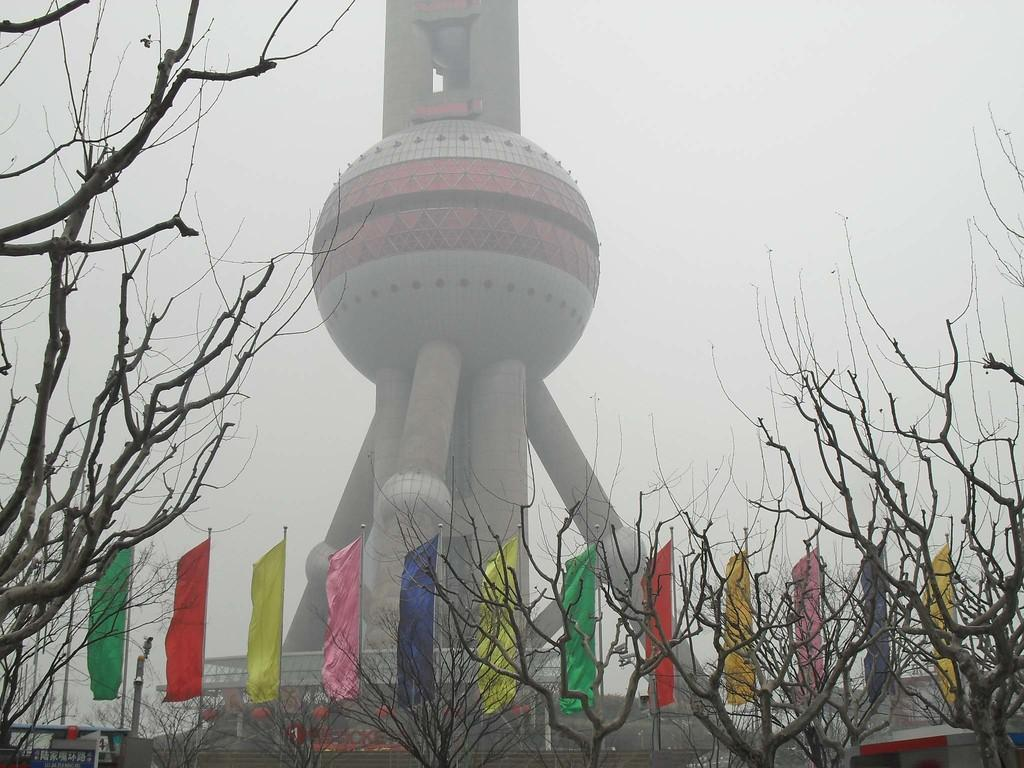What is the main structure in the image? There is a tower in the image. What is attached to the poles in the image? There are flags on poles in the image. What type of vegetation can be seen in the image? There is a group of trees in the image. What type of man-made structures are present in the image? There are buildings in the image. What else can be seen attached to the poles in the image? There are poles in the image. What is the condition of the sky in the image? The sky is visible in the image and appears cloudy. What type of humor can be heard coming from the tower in the image? There is no indication of humor or any sounds in the image, as it features a tower, flags, trees, buildings, and poles. --- Facts: 1. There is a person sitting on a bench in the image. 2. The person is reading a book. 3. There is a tree behind the bench. 4. The ground is visible in the image. 5. There is a fence in the background. Absurd Topics: parrot, fireworks, ocean Conversation: What is the person in the image doing? The person is sitting on a bench in the image. What activity is the person engaged in while sitting on the bench? The person is reading a book. What type of vegetation can be seen behind the bench? There is a tree behind the bench. What is visible beneath the person's feet in the image? The ground is visible in the image. What architectural feature can be seen in the background? There is a fence in the background. Reasoning: Let's think step by step in order to produce the conversation. We start by identifying the main subject in the image, which is the person sitting on the bench. Then, we describe the activity the person is engaged in, which is reading a book. Next, we mention the tree behind the bench and the ground visible beneath the person's feet. Finally, we address the fence in the background. Each question is designed to elicit a specific detail about the image that is known from the provided facts. Absurd Question/Answer: What type of parrot can be seen perched on the fence in the image? There is no parrot present in the image; it features a person sitting on a bench, reading a book, a tree, the ground, and a fence. --- Facts: 1. There is a car in the image. 2. The car is parked on the street. 3. There are buildings in the background. 4. The sky is visible in the image. 5. There are streetlights in the image. Absurd Topics: elephant, rainbow, dance Conversation: 